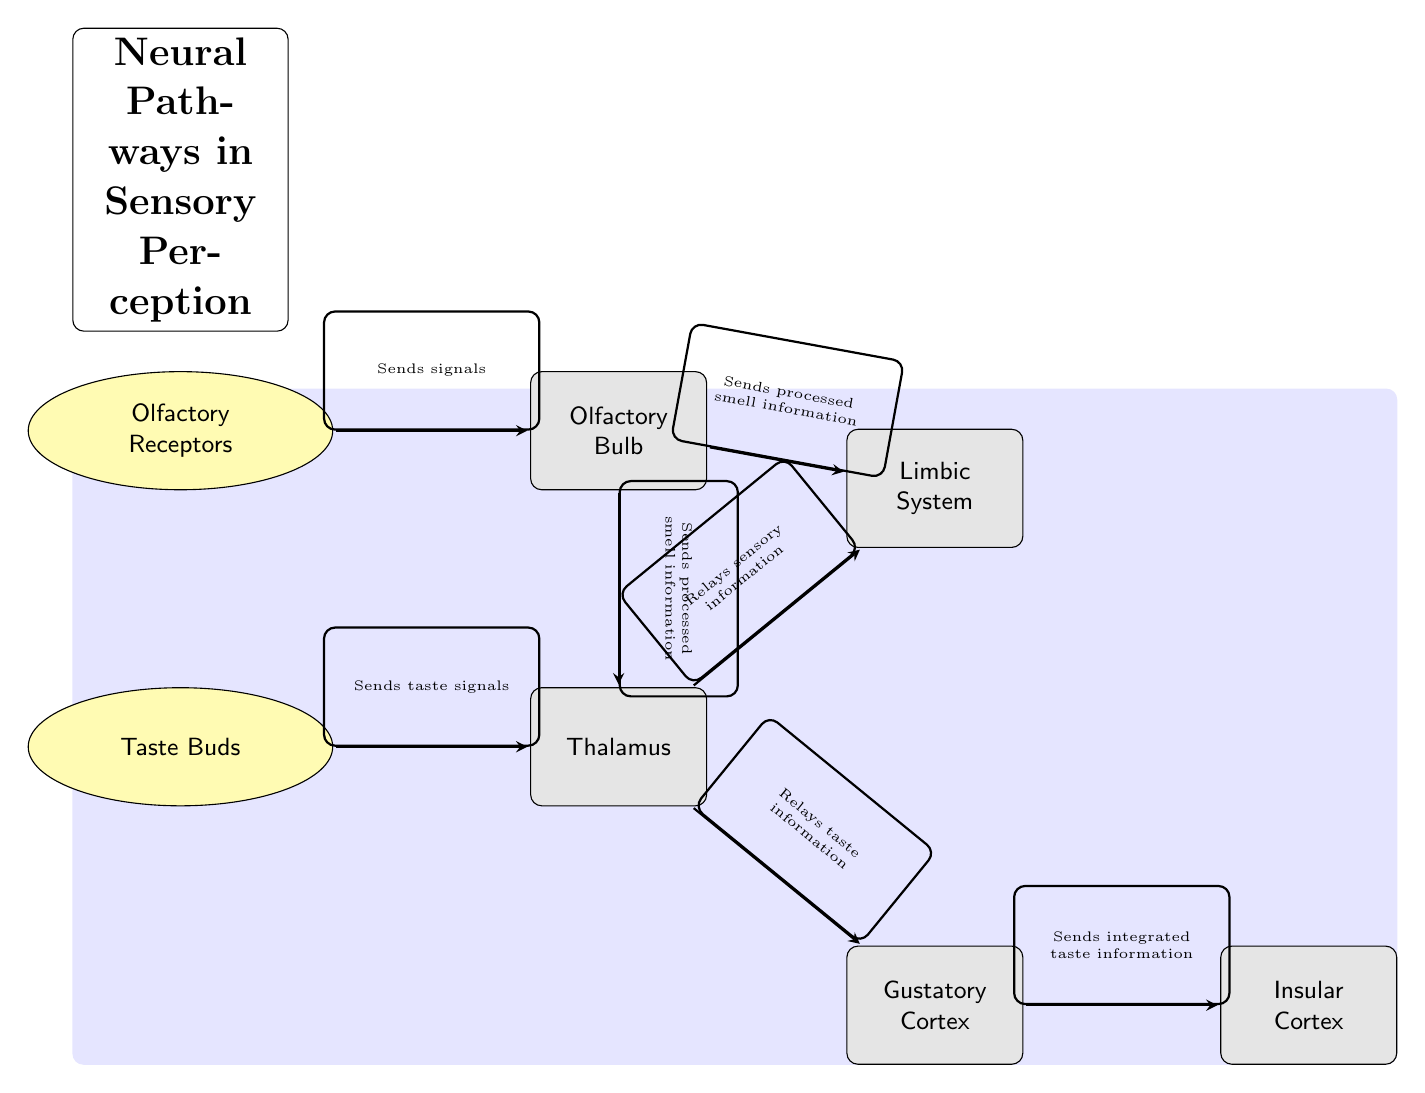What are the two main types of receptors in the diagram? The diagram shows two specific types of receptors: Olfactory Receptors and Taste Buds. These are located at the top and bottom of the diagram, respectively.
Answer: Olfactory Receptors, Taste Buds Which brain part receives processed smell information from the olfactory bulb? The diagram indicates that the processed smell information flows from the olfactory bulb to both the Limbic System and the Thalamus. However, we are looking for one specific answer, which would be the Limbic System, as it is positioned directly above the Thalamus.
Answer: Limbic System How many edges are there connecting the receptors to the brain parts? There are four distinct arrows (edges) showing connections: 2 from the Olfactory Receptors and 2 from the Taste Buds leading to the Thalamus and Olfactory Bulb. Thus, counting these, we can determine there are four edges connecting the receptors to brain parts.
Answer: 4 What role does the Thalamus play in relation to taste and smell? The diagram specifically indicates that the Thalamus relays both taste information from the Taste Buds and sensory information from the Olfactory Bulb to other brain parts. Thus, it acts as a relay point for these sensory inputs.
Answer: Relays information Which brain part is responsible for sending integrated taste information to the insular cortex? According to the diagram, the Gustatory Cortex is responsible for sending integrated taste information to the Insular Cortex, as indicated by the arrow on the right side of the diagram pointing towards the Insular Cortex.
Answer: Gustatory Cortex What type of diagram is represented in the visual shown? The title at the top of the diagram states "Neural Pathways in Sensory Perception" and the components indicate relationships between perception mechanisms, confirming this is a Biomedical diagram focusing on neural pathways and sensory perception.
Answer: Biomedical Diagram Describe the flow of signals from the olfactory receptors to the limbic system. Signals from the Olfactory Receptors first travel to the Olfactory Bulb, which processes the smell information. From there, the processed information is sent to the Limbic System. Therefore, the complete path is Olfactory Receptors → Olfactory Bulb → Limbic System.
Answer: Olfactory Receptors → Olfactory Bulb → Limbic System 